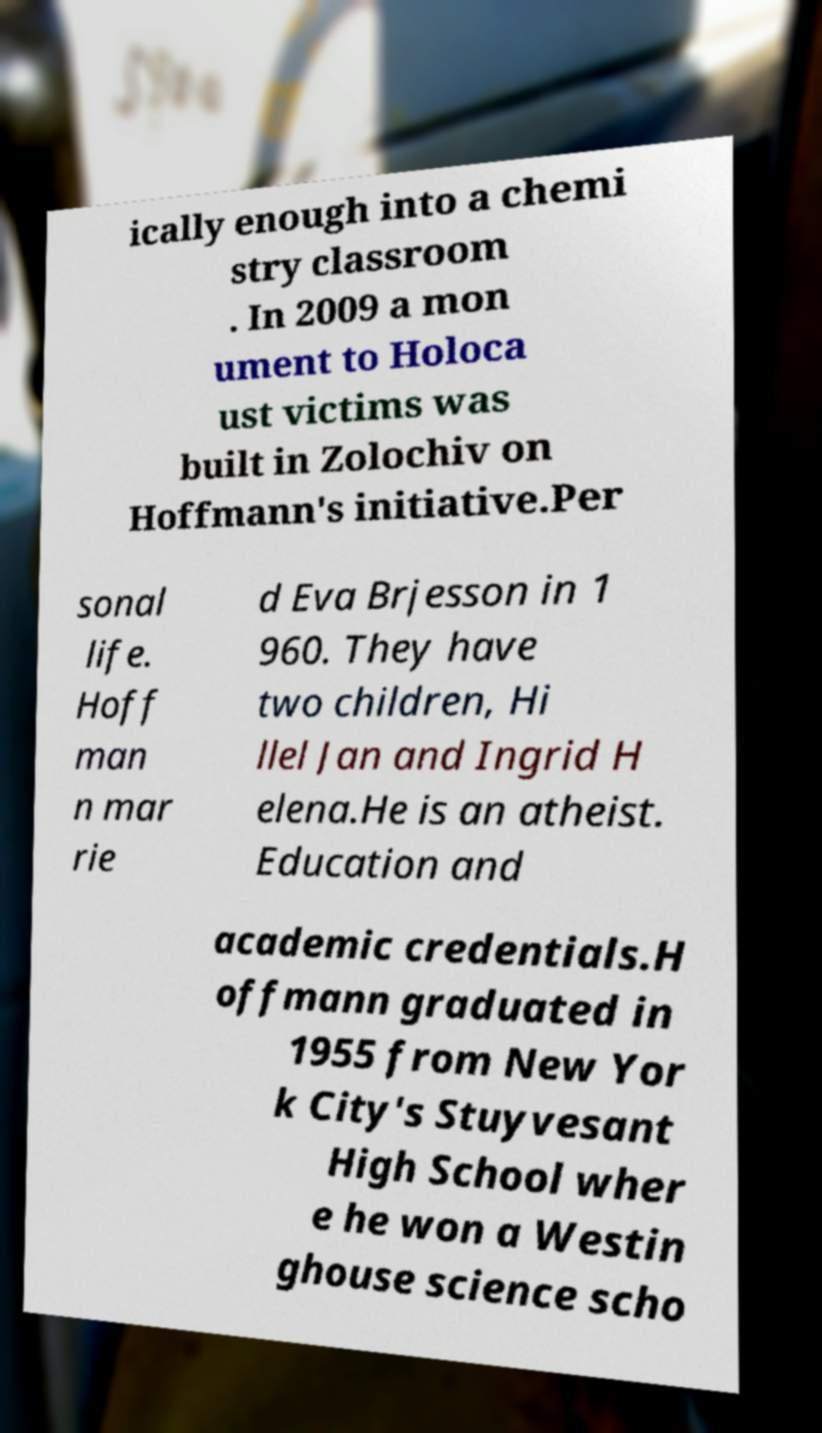What messages or text are displayed in this image? I need them in a readable, typed format. ically enough into a chemi stry classroom . In 2009 a mon ument to Holoca ust victims was built in Zolochiv on Hoffmann's initiative.Per sonal life. Hoff man n mar rie d Eva Brjesson in 1 960. They have two children, Hi llel Jan and Ingrid H elena.He is an atheist. Education and academic credentials.H offmann graduated in 1955 from New Yor k City's Stuyvesant High School wher e he won a Westin ghouse science scho 